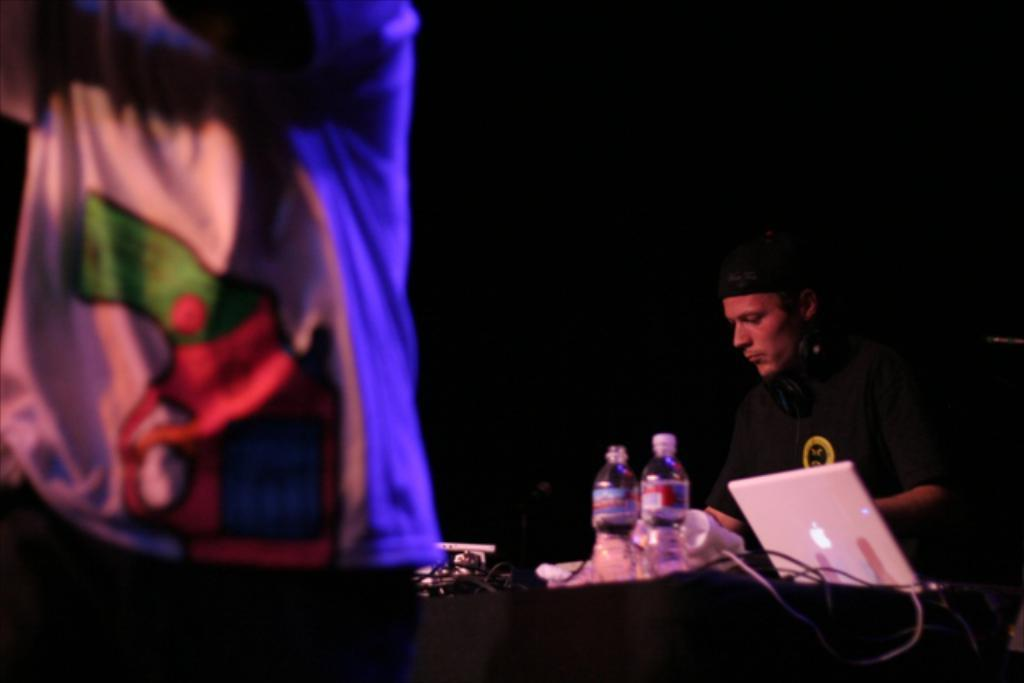How many people are in the image? There are two people in the image. What object is the person using in the image? There is a laptop in the image, which the person might be using. What other items can be seen in the image? There is a bottle, napkins, and cables visible in the image. What is the color of the background in the image? The background of the image is dark. Can you see a volcano erupting in the background of the image? No, there is no volcano or any indication of an eruption in the image. Are there any deer visible in the image? No, there are no deer present in the image. 